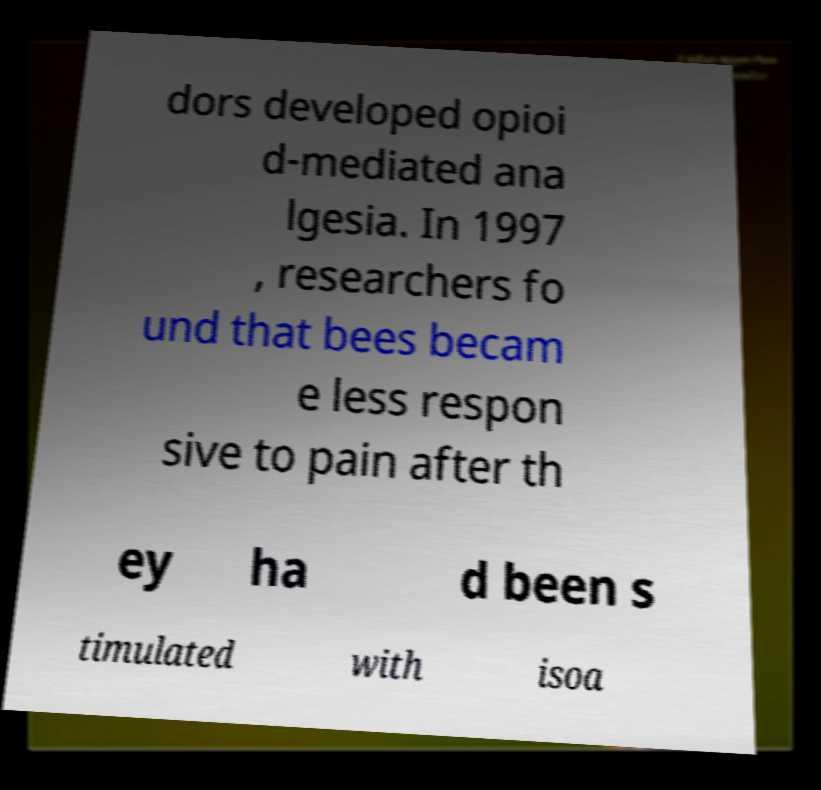Can you accurately transcribe the text from the provided image for me? dors developed opioi d-mediated ana lgesia. In 1997 , researchers fo und that bees becam e less respon sive to pain after th ey ha d been s timulated with isoa 